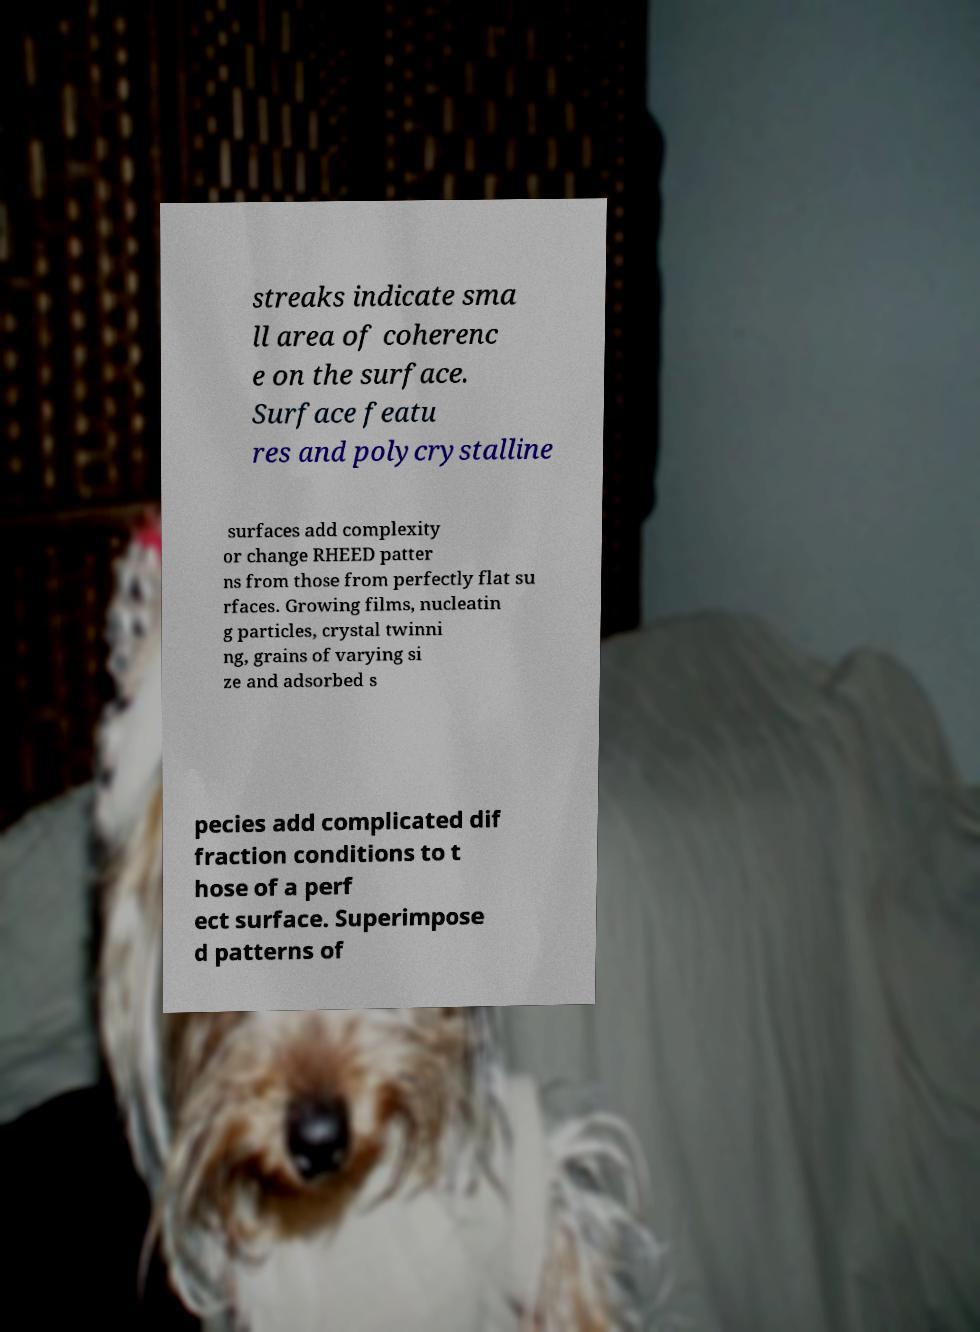Please identify and transcribe the text found in this image. streaks indicate sma ll area of coherenc e on the surface. Surface featu res and polycrystalline surfaces add complexity or change RHEED patter ns from those from perfectly flat su rfaces. Growing films, nucleatin g particles, crystal twinni ng, grains of varying si ze and adsorbed s pecies add complicated dif fraction conditions to t hose of a perf ect surface. Superimpose d patterns of 